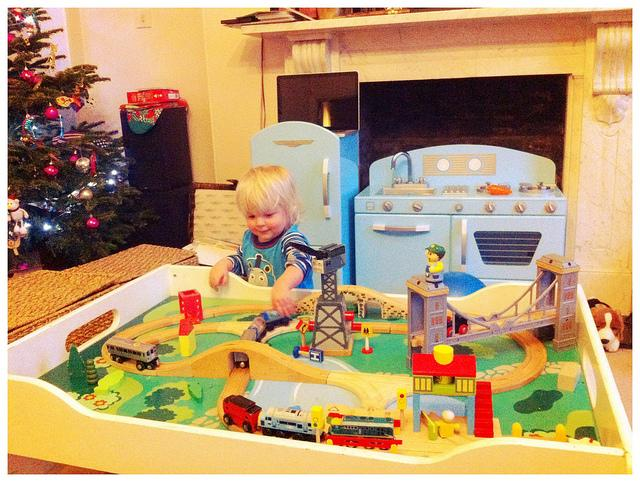What is the child playing with?

Choices:
A) dog
B) train
C) egg
D) cat train 